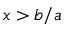Convert formula to latex. <formula><loc_0><loc_0><loc_500><loc_500>x > b / a</formula> 